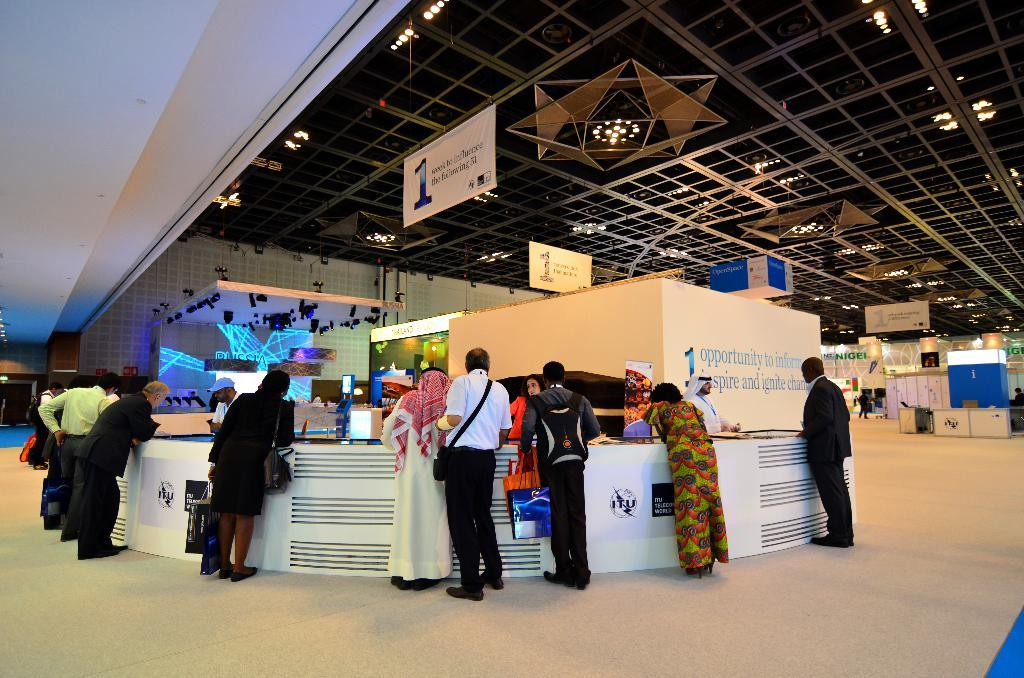How many people are in the image? There is a group of people in the image, but the exact number is not specified. What are the people doing in the image? The people are standing on the floor, carrying bags, banners, screens, and lights. What type of structure is visible in the image? There is a roof and walls visible in the image, suggesting a room or enclosed space. What other objects can be seen in the image? There are other objects present in the image, but their specific nature is not mentioned. What type of sand can be seen on the floor in the image? There is no sand visible on the floor in the image; the floor is covered by people and other objects. 